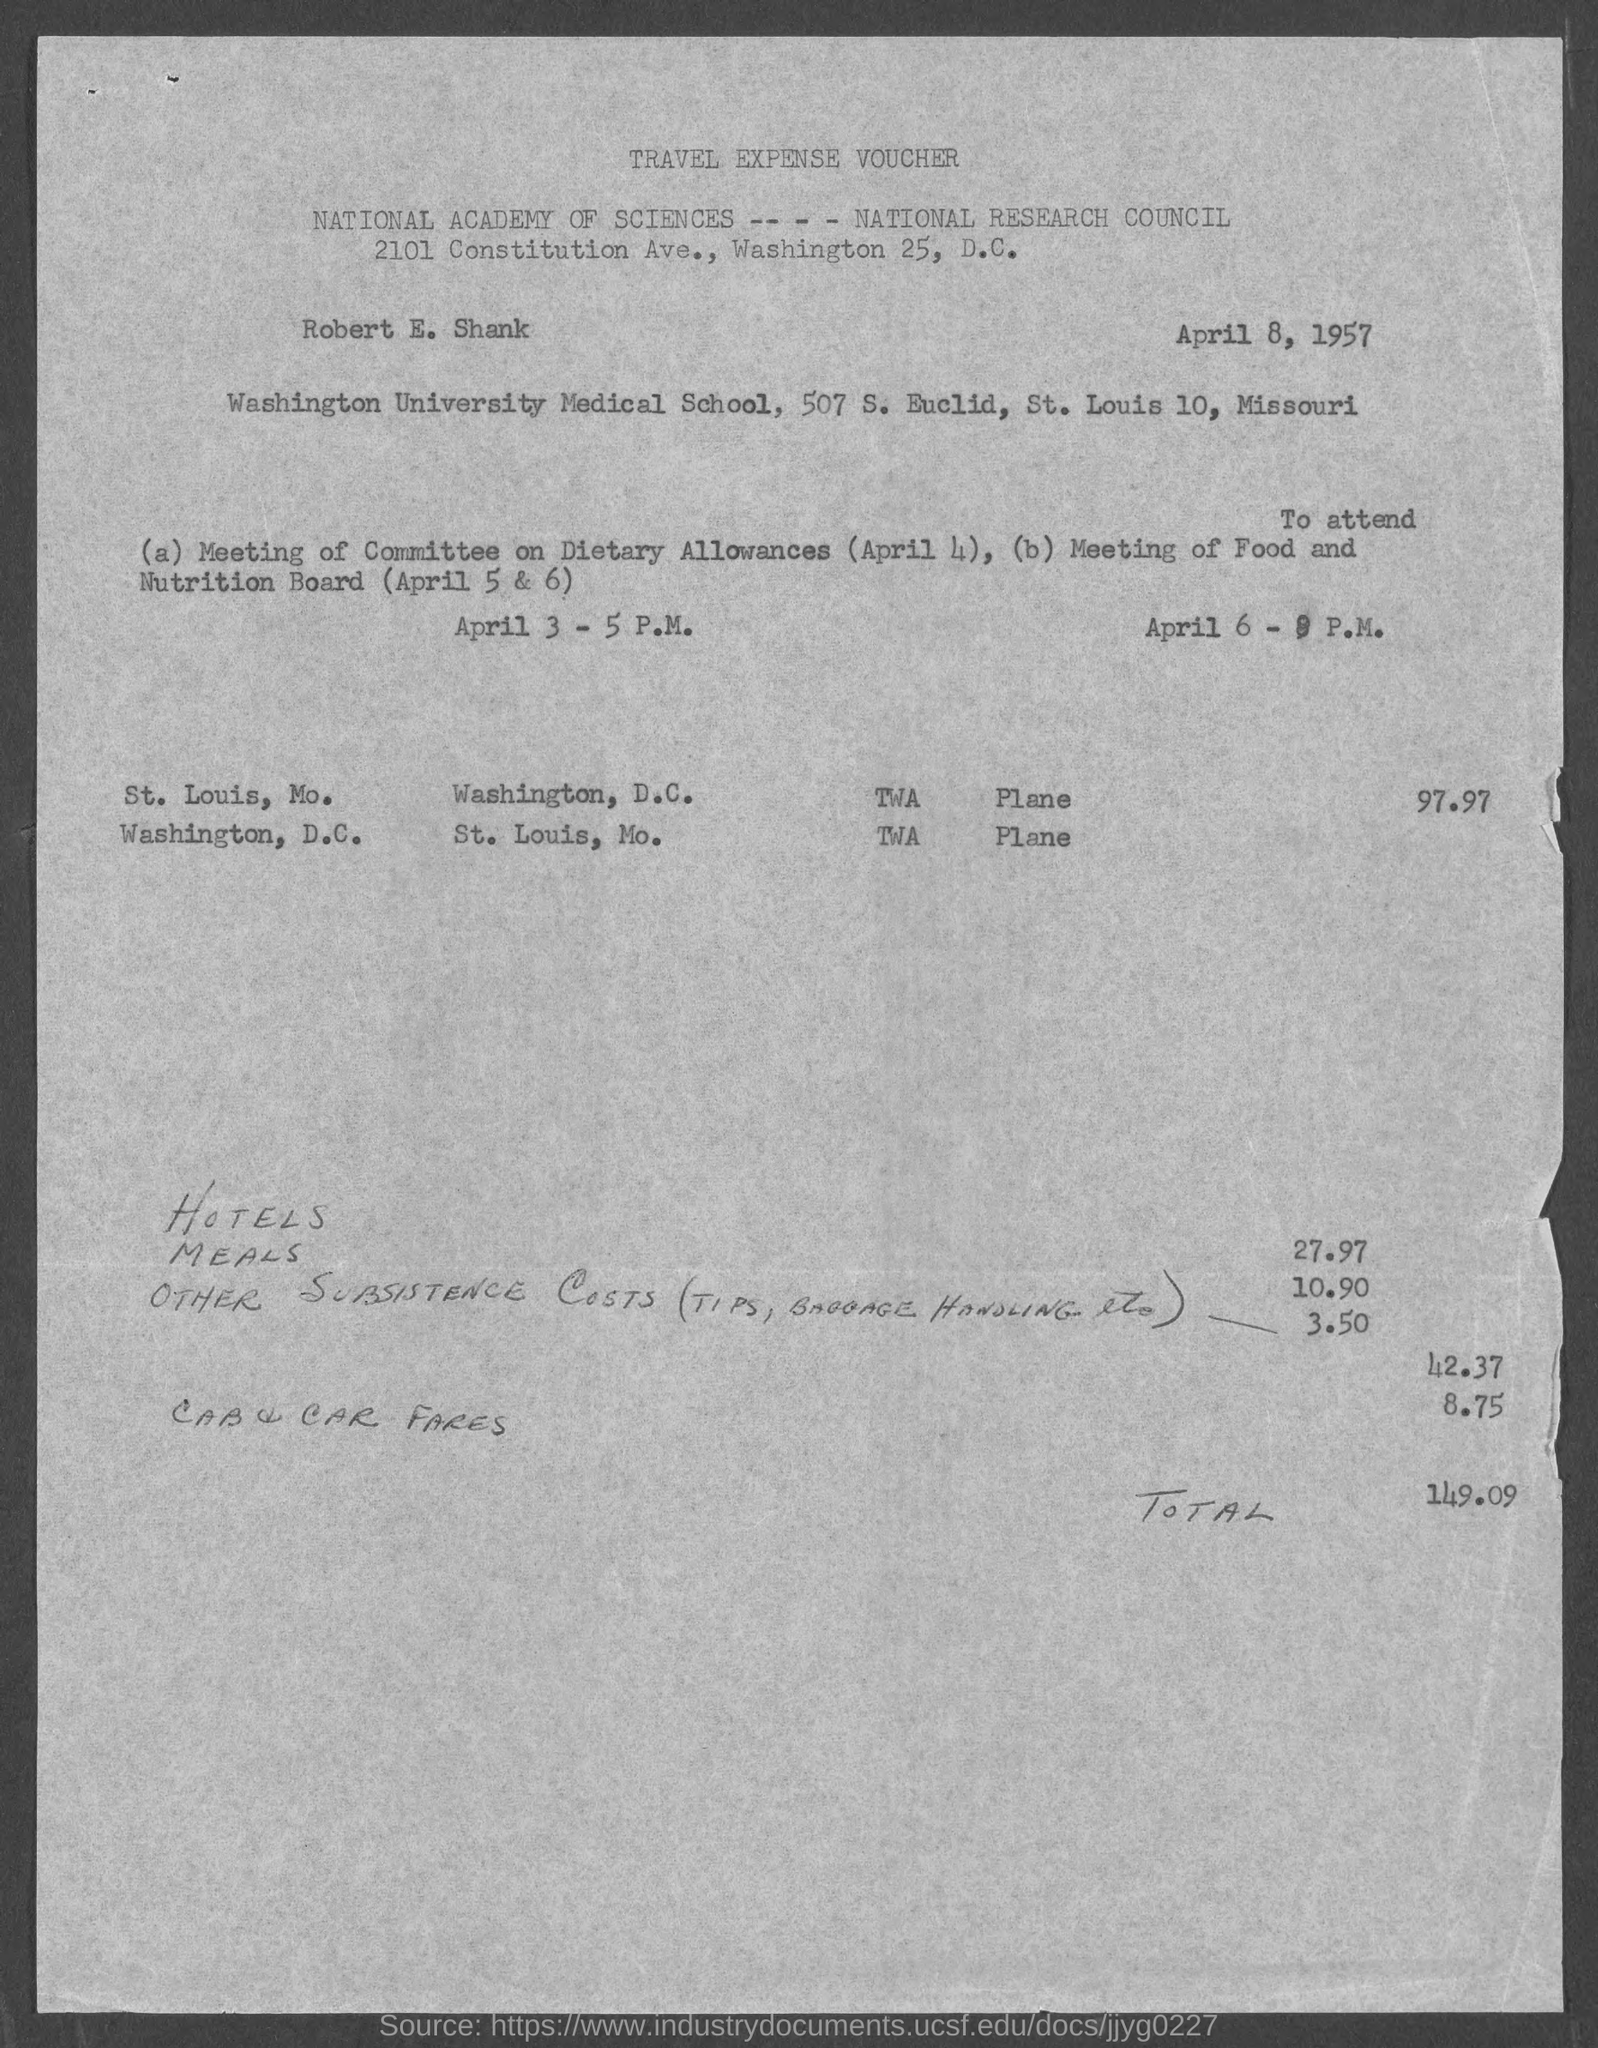What is the name of the person mentioned in the voucher?
Your answer should be compact. Robert E. Shank. What is the issued date of the voucher?
Keep it short and to the point. April 8, 1957. What is the total travel expense mentioned in the voucher?
Provide a short and direct response. 149.09. When is the Meeting of Food and Nutrition Board held?
Ensure brevity in your answer.  (April 5 & 6). What is the expense for other subsistence costs mentioned in the voucher?
Your answer should be very brief. 3.50. 